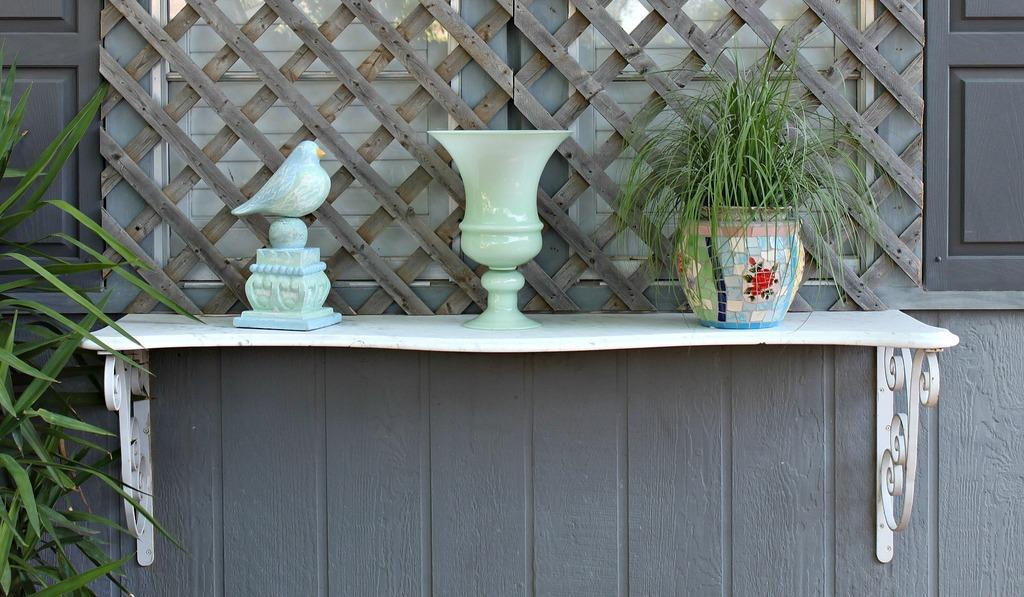Where was the image taken? The image was taken outside a building. What can be seen on the stand in the image? There is a statue, a pot, and a plant pot on the stand. What type of plant is visible in the image? There is a plant on the left side of the image. What can be seen in the background of the image? There is a window and a fence in the background of the image. What type of scarf is the statue wearing in the image? There is no scarf present on the statue in the image. How many trains can be seen passing by in the background of the image? There are no trains visible in the background of the image. 